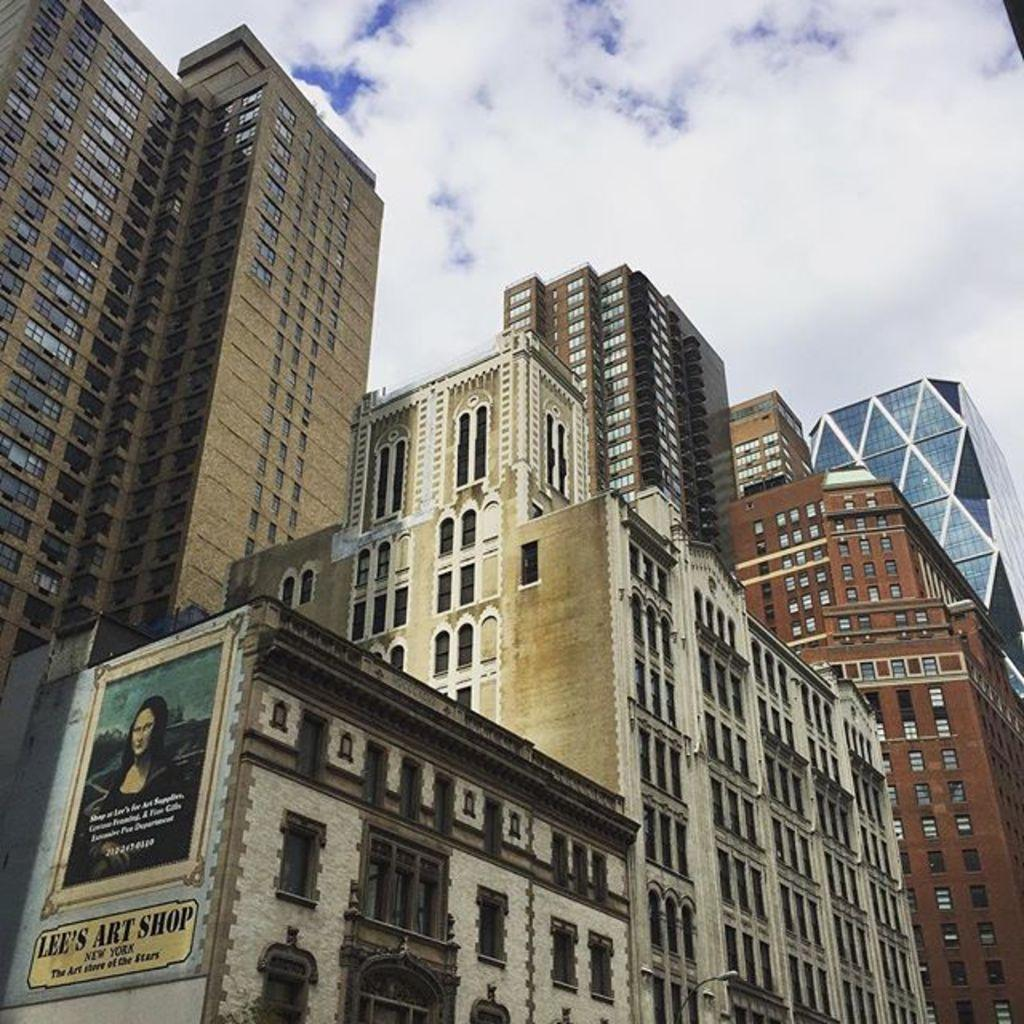What type of structures are present in the image? There are big buildings in the image. What is attached to one of the buildings? There is a board with text and a picture attached to one of the buildings. What can be seen at the top of the image? The sky is visible at the top of the image. Can you see any sea creatures swimming in the image? There is no sea or sea creatures present in the image. What type of underwear is the person wearing in the image? There is no person or underwear visible in the image. 